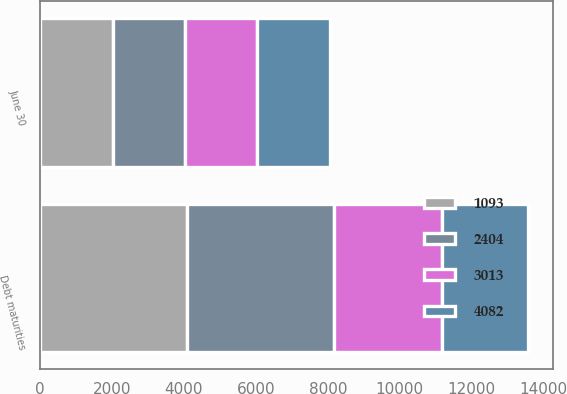<chart> <loc_0><loc_0><loc_500><loc_500><stacked_bar_chart><ecel><fcel>June 30<fcel>Debt maturities<nl><fcel>1093<fcel>2013<fcel>4083<nl><fcel>3013<fcel>2014<fcel>3013<nl><fcel>2404<fcel>2015<fcel>4082<nl><fcel>4082<fcel>2016<fcel>2404<nl></chart> 